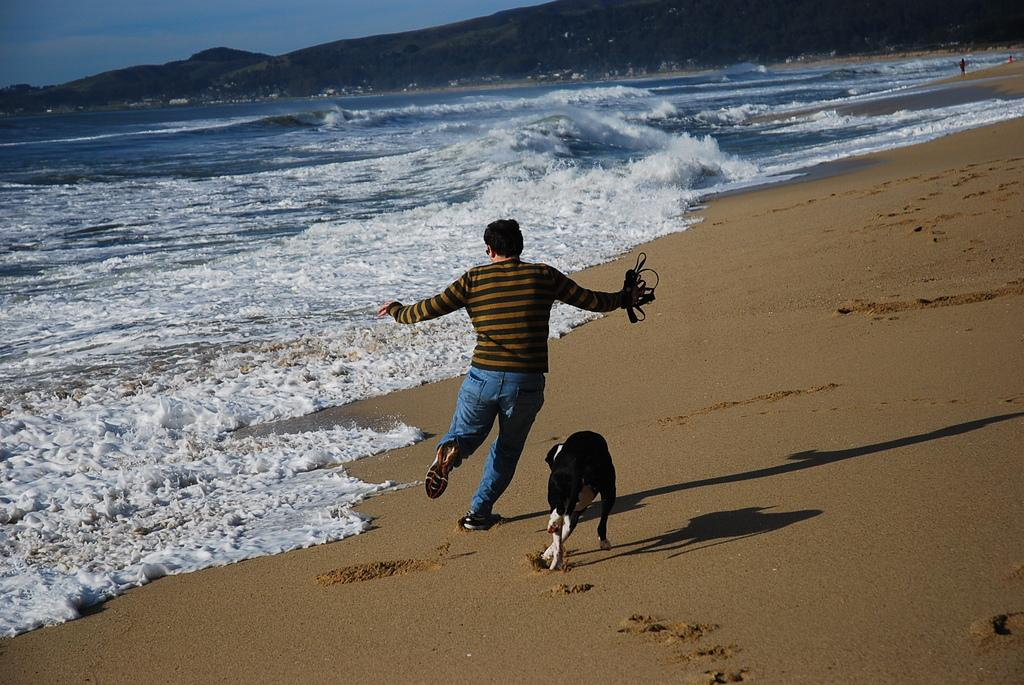What is happening in the image involving a person and a dog? In the image, there is a person running while holding a leash, and a dog is running alongside them. What is the person holding while running? The person is holding a leash in the image. What can be seen in the background of the image? Mountains and water are visible in the background of the image, along with the sky. What is the person arguing about with the goat in the image? There is no goat present in the image, so there cannot be an argument between the person and a goat. Can you see any writing on the mountains in the image? There is no writing visible on the mountains or any other part of the image. 